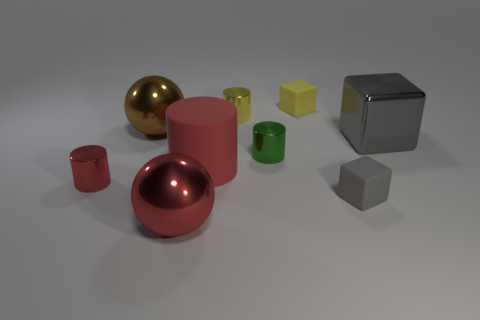What material is the tiny cylinder that is the same color as the big rubber object?
Keep it short and to the point. Metal. There is a big matte object; is its color the same as the big metallic thing in front of the large block?
Your response must be concise. Yes. What size is the thing that is the same color as the shiny block?
Your answer should be compact. Small. Are there any yellow blocks that have the same size as the brown metal ball?
Keep it short and to the point. No. Is the material of the small red cylinder the same as the cylinder that is behind the brown metal sphere?
Give a very brief answer. Yes. Are there more tiny blue things than cylinders?
Offer a terse response. No. What number of cubes are small red matte things or tiny metallic objects?
Offer a terse response. 0. The rubber cylinder has what color?
Your answer should be compact. Red. There is a shiny thing behind the large brown metal sphere; is its size the same as the red shiny object to the left of the large red sphere?
Your answer should be very brief. Yes. Is the number of large rubber cylinders less than the number of large spheres?
Your response must be concise. Yes. 